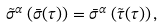Convert formula to latex. <formula><loc_0><loc_0><loc_500><loc_500>\tilde { \sigma } ^ { \alpha } \left ( \bar { \sigma } ( \tau ) \right ) = \bar { \sigma } ^ { \alpha } \left ( \tilde { \tau } ( \tau ) \right ) ,</formula> 